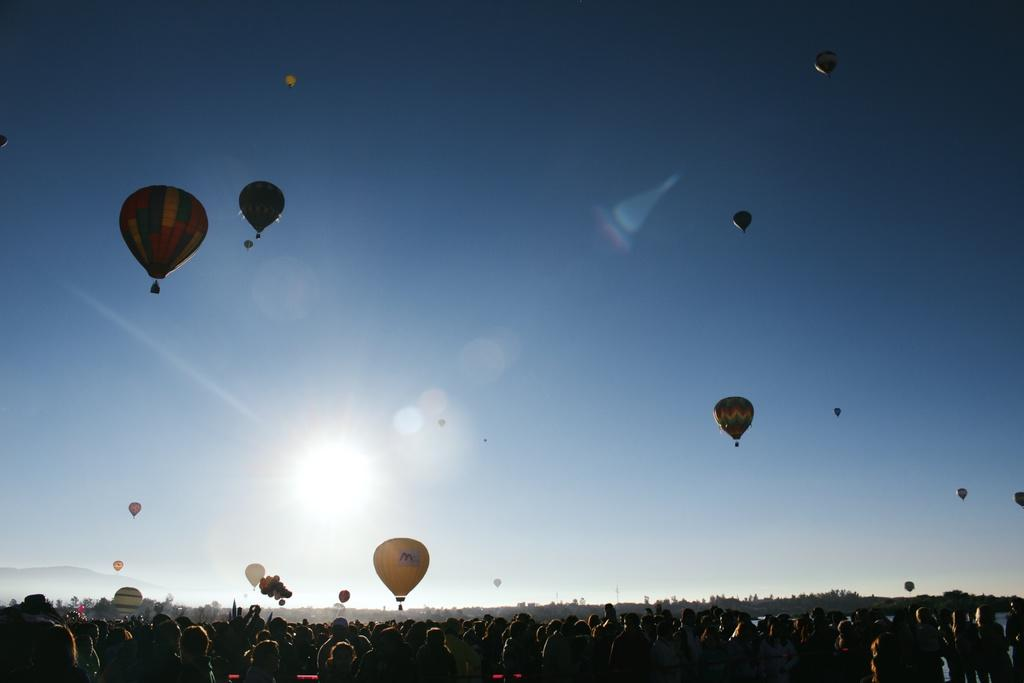How many people are in the image? There is a group of people in the image, but the exact number is not specified. What are the people in the image doing? The people are standing in the image. What else can be seen in the image besides the people? There are parachutes in the image. What is the color of the sky in the image? The sky is blue and white in color. What credit score do the people in the image have? There is no information about the people's credit scores in the image. What level of difficulty are the people attempting in the image? There is no indication of any difficulty level in the image; the people are simply standing. 